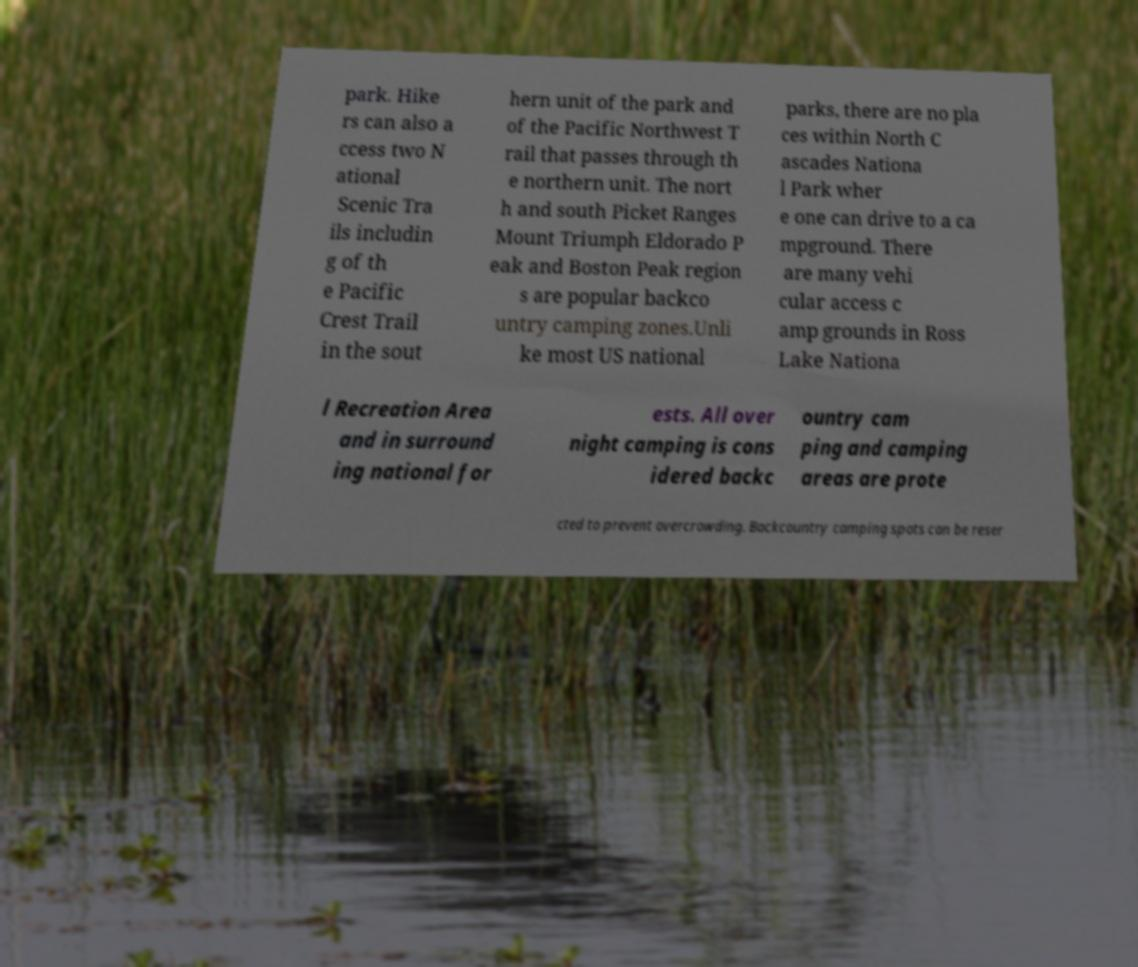For documentation purposes, I need the text within this image transcribed. Could you provide that? park. Hike rs can also a ccess two N ational Scenic Tra ils includin g of th e Pacific Crest Trail in the sout hern unit of the park and of the Pacific Northwest T rail that passes through th e northern unit. The nort h and south Picket Ranges Mount Triumph Eldorado P eak and Boston Peak region s are popular backco untry camping zones.Unli ke most US national parks, there are no pla ces within North C ascades Nationa l Park wher e one can drive to a ca mpground. There are many vehi cular access c amp grounds in Ross Lake Nationa l Recreation Area and in surround ing national for ests. All over night camping is cons idered backc ountry cam ping and camping areas are prote cted to prevent overcrowding. Backcountry camping spots can be reser 